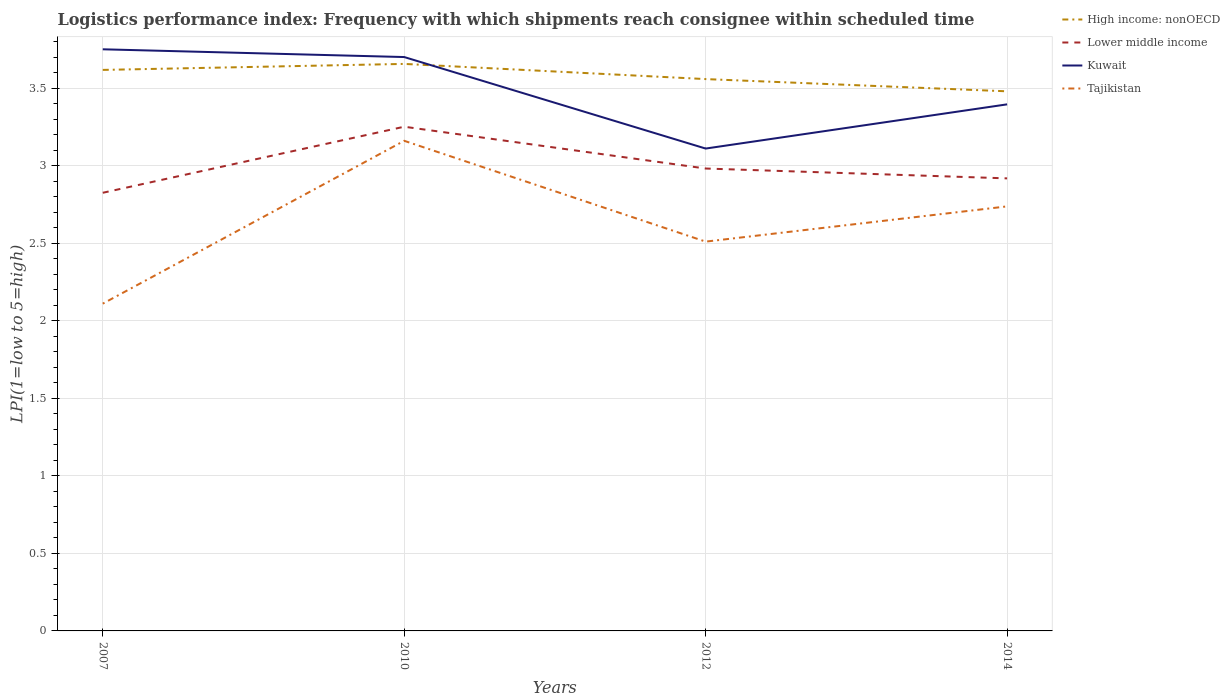Does the line corresponding to High income: nonOECD intersect with the line corresponding to Tajikistan?
Ensure brevity in your answer.  No. Across all years, what is the maximum logistics performance index in Lower middle income?
Provide a succinct answer. 2.82. What is the total logistics performance index in Kuwait in the graph?
Keep it short and to the point. 0.05. What is the difference between the highest and the second highest logistics performance index in Tajikistan?
Provide a succinct answer. 1.05. What is the difference between the highest and the lowest logistics performance index in Lower middle income?
Your response must be concise. 1. What is the difference between two consecutive major ticks on the Y-axis?
Your answer should be compact. 0.5. Does the graph contain any zero values?
Offer a terse response. No. How many legend labels are there?
Keep it short and to the point. 4. How are the legend labels stacked?
Provide a succinct answer. Vertical. What is the title of the graph?
Your response must be concise. Logistics performance index: Frequency with which shipments reach consignee within scheduled time. Does "Sint Maarten (Dutch part)" appear as one of the legend labels in the graph?
Make the answer very short. No. What is the label or title of the X-axis?
Ensure brevity in your answer.  Years. What is the label or title of the Y-axis?
Keep it short and to the point. LPI(1=low to 5=high). What is the LPI(1=low to 5=high) of High income: nonOECD in 2007?
Make the answer very short. 3.62. What is the LPI(1=low to 5=high) of Lower middle income in 2007?
Give a very brief answer. 2.82. What is the LPI(1=low to 5=high) of Kuwait in 2007?
Ensure brevity in your answer.  3.75. What is the LPI(1=low to 5=high) of Tajikistan in 2007?
Ensure brevity in your answer.  2.11. What is the LPI(1=low to 5=high) of High income: nonOECD in 2010?
Give a very brief answer. 3.66. What is the LPI(1=low to 5=high) of Lower middle income in 2010?
Ensure brevity in your answer.  3.25. What is the LPI(1=low to 5=high) in Kuwait in 2010?
Offer a terse response. 3.7. What is the LPI(1=low to 5=high) in Tajikistan in 2010?
Provide a short and direct response. 3.16. What is the LPI(1=low to 5=high) in High income: nonOECD in 2012?
Give a very brief answer. 3.56. What is the LPI(1=low to 5=high) of Lower middle income in 2012?
Provide a succinct answer. 2.98. What is the LPI(1=low to 5=high) in Kuwait in 2012?
Give a very brief answer. 3.11. What is the LPI(1=low to 5=high) in Tajikistan in 2012?
Your answer should be very brief. 2.51. What is the LPI(1=low to 5=high) in High income: nonOECD in 2014?
Provide a succinct answer. 3.48. What is the LPI(1=low to 5=high) of Lower middle income in 2014?
Provide a succinct answer. 2.92. What is the LPI(1=low to 5=high) in Kuwait in 2014?
Ensure brevity in your answer.  3.39. What is the LPI(1=low to 5=high) of Tajikistan in 2014?
Your answer should be compact. 2.74. Across all years, what is the maximum LPI(1=low to 5=high) of High income: nonOECD?
Your response must be concise. 3.66. Across all years, what is the maximum LPI(1=low to 5=high) of Lower middle income?
Provide a short and direct response. 3.25. Across all years, what is the maximum LPI(1=low to 5=high) of Kuwait?
Your answer should be very brief. 3.75. Across all years, what is the maximum LPI(1=low to 5=high) in Tajikistan?
Your answer should be very brief. 3.16. Across all years, what is the minimum LPI(1=low to 5=high) of High income: nonOECD?
Your response must be concise. 3.48. Across all years, what is the minimum LPI(1=low to 5=high) in Lower middle income?
Make the answer very short. 2.82. Across all years, what is the minimum LPI(1=low to 5=high) in Kuwait?
Offer a terse response. 3.11. Across all years, what is the minimum LPI(1=low to 5=high) in Tajikistan?
Your answer should be compact. 2.11. What is the total LPI(1=low to 5=high) in High income: nonOECD in the graph?
Your answer should be compact. 14.31. What is the total LPI(1=low to 5=high) of Lower middle income in the graph?
Offer a very short reply. 11.97. What is the total LPI(1=low to 5=high) of Kuwait in the graph?
Your answer should be compact. 13.96. What is the total LPI(1=low to 5=high) in Tajikistan in the graph?
Make the answer very short. 10.52. What is the difference between the LPI(1=low to 5=high) in High income: nonOECD in 2007 and that in 2010?
Ensure brevity in your answer.  -0.04. What is the difference between the LPI(1=low to 5=high) in Lower middle income in 2007 and that in 2010?
Make the answer very short. -0.43. What is the difference between the LPI(1=low to 5=high) of Kuwait in 2007 and that in 2010?
Provide a short and direct response. 0.05. What is the difference between the LPI(1=low to 5=high) of Tajikistan in 2007 and that in 2010?
Make the answer very short. -1.05. What is the difference between the LPI(1=low to 5=high) in High income: nonOECD in 2007 and that in 2012?
Offer a terse response. 0.06. What is the difference between the LPI(1=low to 5=high) of Lower middle income in 2007 and that in 2012?
Your response must be concise. -0.16. What is the difference between the LPI(1=low to 5=high) in Kuwait in 2007 and that in 2012?
Your answer should be compact. 0.64. What is the difference between the LPI(1=low to 5=high) in High income: nonOECD in 2007 and that in 2014?
Ensure brevity in your answer.  0.14. What is the difference between the LPI(1=low to 5=high) of Lower middle income in 2007 and that in 2014?
Provide a short and direct response. -0.09. What is the difference between the LPI(1=low to 5=high) in Kuwait in 2007 and that in 2014?
Your answer should be compact. 0.35. What is the difference between the LPI(1=low to 5=high) in Tajikistan in 2007 and that in 2014?
Your answer should be compact. -0.63. What is the difference between the LPI(1=low to 5=high) in High income: nonOECD in 2010 and that in 2012?
Offer a very short reply. 0.1. What is the difference between the LPI(1=low to 5=high) of Lower middle income in 2010 and that in 2012?
Provide a succinct answer. 0.27. What is the difference between the LPI(1=low to 5=high) in Kuwait in 2010 and that in 2012?
Give a very brief answer. 0.59. What is the difference between the LPI(1=low to 5=high) in Tajikistan in 2010 and that in 2012?
Offer a terse response. 0.65. What is the difference between the LPI(1=low to 5=high) in High income: nonOECD in 2010 and that in 2014?
Provide a short and direct response. 0.18. What is the difference between the LPI(1=low to 5=high) of Lower middle income in 2010 and that in 2014?
Provide a succinct answer. 0.33. What is the difference between the LPI(1=low to 5=high) in Kuwait in 2010 and that in 2014?
Provide a succinct answer. 0.3. What is the difference between the LPI(1=low to 5=high) in Tajikistan in 2010 and that in 2014?
Provide a succinct answer. 0.42. What is the difference between the LPI(1=low to 5=high) of High income: nonOECD in 2012 and that in 2014?
Your response must be concise. 0.08. What is the difference between the LPI(1=low to 5=high) of Lower middle income in 2012 and that in 2014?
Offer a terse response. 0.06. What is the difference between the LPI(1=low to 5=high) of Kuwait in 2012 and that in 2014?
Provide a succinct answer. -0.28. What is the difference between the LPI(1=low to 5=high) in Tajikistan in 2012 and that in 2014?
Provide a short and direct response. -0.23. What is the difference between the LPI(1=low to 5=high) of High income: nonOECD in 2007 and the LPI(1=low to 5=high) of Lower middle income in 2010?
Keep it short and to the point. 0.37. What is the difference between the LPI(1=low to 5=high) of High income: nonOECD in 2007 and the LPI(1=low to 5=high) of Kuwait in 2010?
Make the answer very short. -0.08. What is the difference between the LPI(1=low to 5=high) in High income: nonOECD in 2007 and the LPI(1=low to 5=high) in Tajikistan in 2010?
Your response must be concise. 0.46. What is the difference between the LPI(1=low to 5=high) of Lower middle income in 2007 and the LPI(1=low to 5=high) of Kuwait in 2010?
Provide a succinct answer. -0.88. What is the difference between the LPI(1=low to 5=high) of Lower middle income in 2007 and the LPI(1=low to 5=high) of Tajikistan in 2010?
Give a very brief answer. -0.34. What is the difference between the LPI(1=low to 5=high) of Kuwait in 2007 and the LPI(1=low to 5=high) of Tajikistan in 2010?
Provide a succinct answer. 0.59. What is the difference between the LPI(1=low to 5=high) of High income: nonOECD in 2007 and the LPI(1=low to 5=high) of Lower middle income in 2012?
Your answer should be compact. 0.64. What is the difference between the LPI(1=low to 5=high) of High income: nonOECD in 2007 and the LPI(1=low to 5=high) of Kuwait in 2012?
Your answer should be compact. 0.51. What is the difference between the LPI(1=low to 5=high) in High income: nonOECD in 2007 and the LPI(1=low to 5=high) in Tajikistan in 2012?
Make the answer very short. 1.11. What is the difference between the LPI(1=low to 5=high) of Lower middle income in 2007 and the LPI(1=low to 5=high) of Kuwait in 2012?
Offer a very short reply. -0.29. What is the difference between the LPI(1=low to 5=high) of Lower middle income in 2007 and the LPI(1=low to 5=high) of Tajikistan in 2012?
Make the answer very short. 0.31. What is the difference between the LPI(1=low to 5=high) in Kuwait in 2007 and the LPI(1=low to 5=high) in Tajikistan in 2012?
Your answer should be very brief. 1.24. What is the difference between the LPI(1=low to 5=high) in High income: nonOECD in 2007 and the LPI(1=low to 5=high) in Lower middle income in 2014?
Give a very brief answer. 0.7. What is the difference between the LPI(1=low to 5=high) of High income: nonOECD in 2007 and the LPI(1=low to 5=high) of Kuwait in 2014?
Provide a succinct answer. 0.22. What is the difference between the LPI(1=low to 5=high) in High income: nonOECD in 2007 and the LPI(1=low to 5=high) in Tajikistan in 2014?
Offer a terse response. 0.88. What is the difference between the LPI(1=low to 5=high) of Lower middle income in 2007 and the LPI(1=low to 5=high) of Kuwait in 2014?
Offer a very short reply. -0.57. What is the difference between the LPI(1=low to 5=high) in Lower middle income in 2007 and the LPI(1=low to 5=high) in Tajikistan in 2014?
Keep it short and to the point. 0.09. What is the difference between the LPI(1=low to 5=high) in Kuwait in 2007 and the LPI(1=low to 5=high) in Tajikistan in 2014?
Your response must be concise. 1.01. What is the difference between the LPI(1=low to 5=high) of High income: nonOECD in 2010 and the LPI(1=low to 5=high) of Lower middle income in 2012?
Make the answer very short. 0.67. What is the difference between the LPI(1=low to 5=high) in High income: nonOECD in 2010 and the LPI(1=low to 5=high) in Kuwait in 2012?
Make the answer very short. 0.55. What is the difference between the LPI(1=low to 5=high) in High income: nonOECD in 2010 and the LPI(1=low to 5=high) in Tajikistan in 2012?
Your response must be concise. 1.15. What is the difference between the LPI(1=low to 5=high) in Lower middle income in 2010 and the LPI(1=low to 5=high) in Kuwait in 2012?
Keep it short and to the point. 0.14. What is the difference between the LPI(1=low to 5=high) in Lower middle income in 2010 and the LPI(1=low to 5=high) in Tajikistan in 2012?
Make the answer very short. 0.74. What is the difference between the LPI(1=low to 5=high) in Kuwait in 2010 and the LPI(1=low to 5=high) in Tajikistan in 2012?
Your answer should be compact. 1.19. What is the difference between the LPI(1=low to 5=high) of High income: nonOECD in 2010 and the LPI(1=low to 5=high) of Lower middle income in 2014?
Your response must be concise. 0.74. What is the difference between the LPI(1=low to 5=high) of High income: nonOECD in 2010 and the LPI(1=low to 5=high) of Kuwait in 2014?
Provide a short and direct response. 0.26. What is the difference between the LPI(1=low to 5=high) of High income: nonOECD in 2010 and the LPI(1=low to 5=high) of Tajikistan in 2014?
Ensure brevity in your answer.  0.92. What is the difference between the LPI(1=low to 5=high) of Lower middle income in 2010 and the LPI(1=low to 5=high) of Kuwait in 2014?
Offer a terse response. -0.14. What is the difference between the LPI(1=low to 5=high) in Lower middle income in 2010 and the LPI(1=low to 5=high) in Tajikistan in 2014?
Your answer should be compact. 0.51. What is the difference between the LPI(1=low to 5=high) in Kuwait in 2010 and the LPI(1=low to 5=high) in Tajikistan in 2014?
Your response must be concise. 0.96. What is the difference between the LPI(1=low to 5=high) in High income: nonOECD in 2012 and the LPI(1=low to 5=high) in Lower middle income in 2014?
Offer a terse response. 0.64. What is the difference between the LPI(1=low to 5=high) of High income: nonOECD in 2012 and the LPI(1=low to 5=high) of Kuwait in 2014?
Offer a terse response. 0.16. What is the difference between the LPI(1=low to 5=high) in High income: nonOECD in 2012 and the LPI(1=low to 5=high) in Tajikistan in 2014?
Offer a terse response. 0.82. What is the difference between the LPI(1=low to 5=high) of Lower middle income in 2012 and the LPI(1=low to 5=high) of Kuwait in 2014?
Offer a terse response. -0.41. What is the difference between the LPI(1=low to 5=high) of Lower middle income in 2012 and the LPI(1=low to 5=high) of Tajikistan in 2014?
Provide a succinct answer. 0.24. What is the difference between the LPI(1=low to 5=high) in Kuwait in 2012 and the LPI(1=low to 5=high) in Tajikistan in 2014?
Your answer should be compact. 0.37. What is the average LPI(1=low to 5=high) of High income: nonOECD per year?
Provide a succinct answer. 3.58. What is the average LPI(1=low to 5=high) in Lower middle income per year?
Your answer should be very brief. 2.99. What is the average LPI(1=low to 5=high) of Kuwait per year?
Keep it short and to the point. 3.49. What is the average LPI(1=low to 5=high) in Tajikistan per year?
Your answer should be compact. 2.63. In the year 2007, what is the difference between the LPI(1=low to 5=high) of High income: nonOECD and LPI(1=low to 5=high) of Lower middle income?
Your response must be concise. 0.79. In the year 2007, what is the difference between the LPI(1=low to 5=high) of High income: nonOECD and LPI(1=low to 5=high) of Kuwait?
Your answer should be compact. -0.13. In the year 2007, what is the difference between the LPI(1=low to 5=high) in High income: nonOECD and LPI(1=low to 5=high) in Tajikistan?
Provide a short and direct response. 1.51. In the year 2007, what is the difference between the LPI(1=low to 5=high) in Lower middle income and LPI(1=low to 5=high) in Kuwait?
Ensure brevity in your answer.  -0.93. In the year 2007, what is the difference between the LPI(1=low to 5=high) in Lower middle income and LPI(1=low to 5=high) in Tajikistan?
Offer a very short reply. 0.71. In the year 2007, what is the difference between the LPI(1=low to 5=high) in Kuwait and LPI(1=low to 5=high) in Tajikistan?
Provide a short and direct response. 1.64. In the year 2010, what is the difference between the LPI(1=low to 5=high) in High income: nonOECD and LPI(1=low to 5=high) in Lower middle income?
Offer a very short reply. 0.41. In the year 2010, what is the difference between the LPI(1=low to 5=high) of High income: nonOECD and LPI(1=low to 5=high) of Kuwait?
Your answer should be compact. -0.04. In the year 2010, what is the difference between the LPI(1=low to 5=high) of High income: nonOECD and LPI(1=low to 5=high) of Tajikistan?
Offer a very short reply. 0.5. In the year 2010, what is the difference between the LPI(1=low to 5=high) in Lower middle income and LPI(1=low to 5=high) in Kuwait?
Make the answer very short. -0.45. In the year 2010, what is the difference between the LPI(1=low to 5=high) in Lower middle income and LPI(1=low to 5=high) in Tajikistan?
Offer a very short reply. 0.09. In the year 2010, what is the difference between the LPI(1=low to 5=high) in Kuwait and LPI(1=low to 5=high) in Tajikistan?
Offer a terse response. 0.54. In the year 2012, what is the difference between the LPI(1=low to 5=high) of High income: nonOECD and LPI(1=low to 5=high) of Lower middle income?
Your answer should be compact. 0.58. In the year 2012, what is the difference between the LPI(1=low to 5=high) in High income: nonOECD and LPI(1=low to 5=high) in Kuwait?
Ensure brevity in your answer.  0.45. In the year 2012, what is the difference between the LPI(1=low to 5=high) of High income: nonOECD and LPI(1=low to 5=high) of Tajikistan?
Ensure brevity in your answer.  1.05. In the year 2012, what is the difference between the LPI(1=low to 5=high) of Lower middle income and LPI(1=low to 5=high) of Kuwait?
Offer a terse response. -0.13. In the year 2012, what is the difference between the LPI(1=low to 5=high) of Lower middle income and LPI(1=low to 5=high) of Tajikistan?
Offer a very short reply. 0.47. In the year 2014, what is the difference between the LPI(1=low to 5=high) in High income: nonOECD and LPI(1=low to 5=high) in Lower middle income?
Offer a terse response. 0.56. In the year 2014, what is the difference between the LPI(1=low to 5=high) of High income: nonOECD and LPI(1=low to 5=high) of Kuwait?
Provide a short and direct response. 0.08. In the year 2014, what is the difference between the LPI(1=low to 5=high) in High income: nonOECD and LPI(1=low to 5=high) in Tajikistan?
Make the answer very short. 0.74. In the year 2014, what is the difference between the LPI(1=low to 5=high) in Lower middle income and LPI(1=low to 5=high) in Kuwait?
Keep it short and to the point. -0.48. In the year 2014, what is the difference between the LPI(1=low to 5=high) of Lower middle income and LPI(1=low to 5=high) of Tajikistan?
Give a very brief answer. 0.18. In the year 2014, what is the difference between the LPI(1=low to 5=high) of Kuwait and LPI(1=low to 5=high) of Tajikistan?
Provide a succinct answer. 0.66. What is the ratio of the LPI(1=low to 5=high) of Lower middle income in 2007 to that in 2010?
Keep it short and to the point. 0.87. What is the ratio of the LPI(1=low to 5=high) in Kuwait in 2007 to that in 2010?
Make the answer very short. 1.01. What is the ratio of the LPI(1=low to 5=high) of Tajikistan in 2007 to that in 2010?
Offer a terse response. 0.67. What is the ratio of the LPI(1=low to 5=high) in High income: nonOECD in 2007 to that in 2012?
Offer a terse response. 1.02. What is the ratio of the LPI(1=low to 5=high) of Lower middle income in 2007 to that in 2012?
Your response must be concise. 0.95. What is the ratio of the LPI(1=low to 5=high) in Kuwait in 2007 to that in 2012?
Offer a terse response. 1.21. What is the ratio of the LPI(1=low to 5=high) in Tajikistan in 2007 to that in 2012?
Keep it short and to the point. 0.84. What is the ratio of the LPI(1=low to 5=high) in High income: nonOECD in 2007 to that in 2014?
Make the answer very short. 1.04. What is the ratio of the LPI(1=low to 5=high) of Lower middle income in 2007 to that in 2014?
Your answer should be very brief. 0.97. What is the ratio of the LPI(1=low to 5=high) in Kuwait in 2007 to that in 2014?
Your response must be concise. 1.1. What is the ratio of the LPI(1=low to 5=high) in Tajikistan in 2007 to that in 2014?
Offer a terse response. 0.77. What is the ratio of the LPI(1=low to 5=high) in High income: nonOECD in 2010 to that in 2012?
Your answer should be compact. 1.03. What is the ratio of the LPI(1=low to 5=high) in Lower middle income in 2010 to that in 2012?
Offer a very short reply. 1.09. What is the ratio of the LPI(1=low to 5=high) of Kuwait in 2010 to that in 2012?
Give a very brief answer. 1.19. What is the ratio of the LPI(1=low to 5=high) of Tajikistan in 2010 to that in 2012?
Ensure brevity in your answer.  1.26. What is the ratio of the LPI(1=low to 5=high) of High income: nonOECD in 2010 to that in 2014?
Your response must be concise. 1.05. What is the ratio of the LPI(1=low to 5=high) of Lower middle income in 2010 to that in 2014?
Your answer should be compact. 1.11. What is the ratio of the LPI(1=low to 5=high) of Kuwait in 2010 to that in 2014?
Ensure brevity in your answer.  1.09. What is the ratio of the LPI(1=low to 5=high) of Tajikistan in 2010 to that in 2014?
Provide a succinct answer. 1.15. What is the ratio of the LPI(1=low to 5=high) of High income: nonOECD in 2012 to that in 2014?
Provide a short and direct response. 1.02. What is the ratio of the LPI(1=low to 5=high) of Lower middle income in 2012 to that in 2014?
Keep it short and to the point. 1.02. What is the ratio of the LPI(1=low to 5=high) in Kuwait in 2012 to that in 2014?
Ensure brevity in your answer.  0.92. What is the ratio of the LPI(1=low to 5=high) in Tajikistan in 2012 to that in 2014?
Your answer should be compact. 0.92. What is the difference between the highest and the second highest LPI(1=low to 5=high) of High income: nonOECD?
Ensure brevity in your answer.  0.04. What is the difference between the highest and the second highest LPI(1=low to 5=high) in Lower middle income?
Offer a very short reply. 0.27. What is the difference between the highest and the second highest LPI(1=low to 5=high) in Kuwait?
Give a very brief answer. 0.05. What is the difference between the highest and the second highest LPI(1=low to 5=high) in Tajikistan?
Your answer should be very brief. 0.42. What is the difference between the highest and the lowest LPI(1=low to 5=high) in High income: nonOECD?
Provide a succinct answer. 0.18. What is the difference between the highest and the lowest LPI(1=low to 5=high) in Lower middle income?
Make the answer very short. 0.43. What is the difference between the highest and the lowest LPI(1=low to 5=high) in Kuwait?
Your response must be concise. 0.64. What is the difference between the highest and the lowest LPI(1=low to 5=high) in Tajikistan?
Your response must be concise. 1.05. 